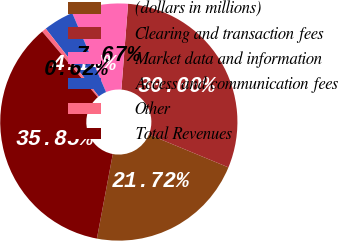Convert chart to OTSL. <chart><loc_0><loc_0><loc_500><loc_500><pie_chart><fcel>(dollars in millions)<fcel>Clearing and transaction fees<fcel>Market data and information<fcel>Access and communication fees<fcel>Other<fcel>Total Revenues<nl><fcel>21.72%<fcel>30.0%<fcel>7.67%<fcel>4.14%<fcel>0.62%<fcel>35.85%<nl></chart> 